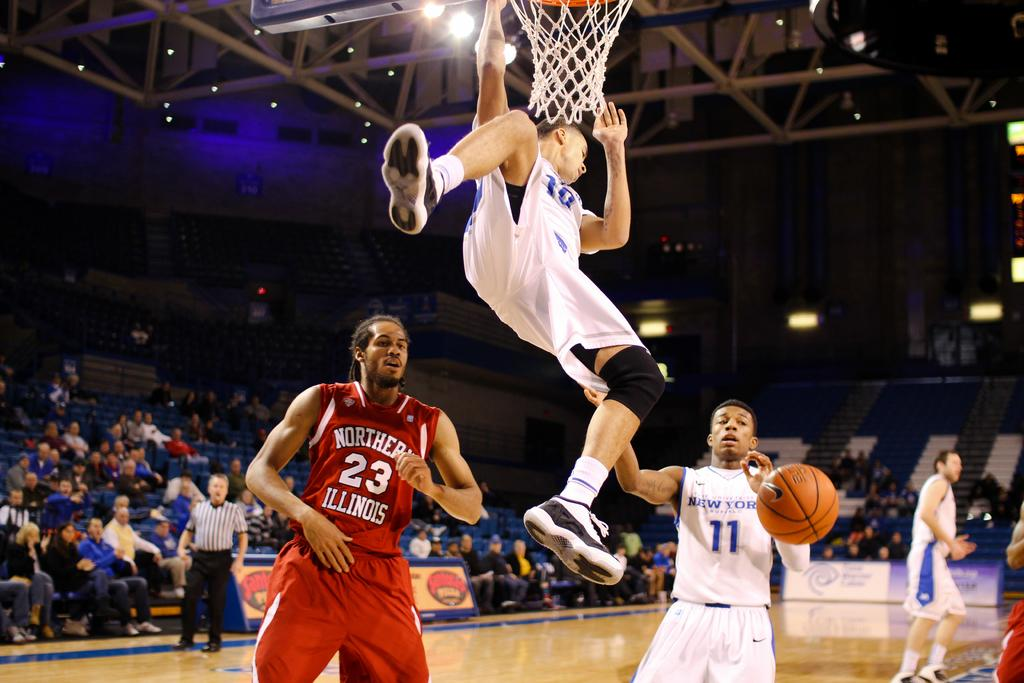<image>
Relay a brief, clear account of the picture shown. the player 23 under a guy who just dunked 